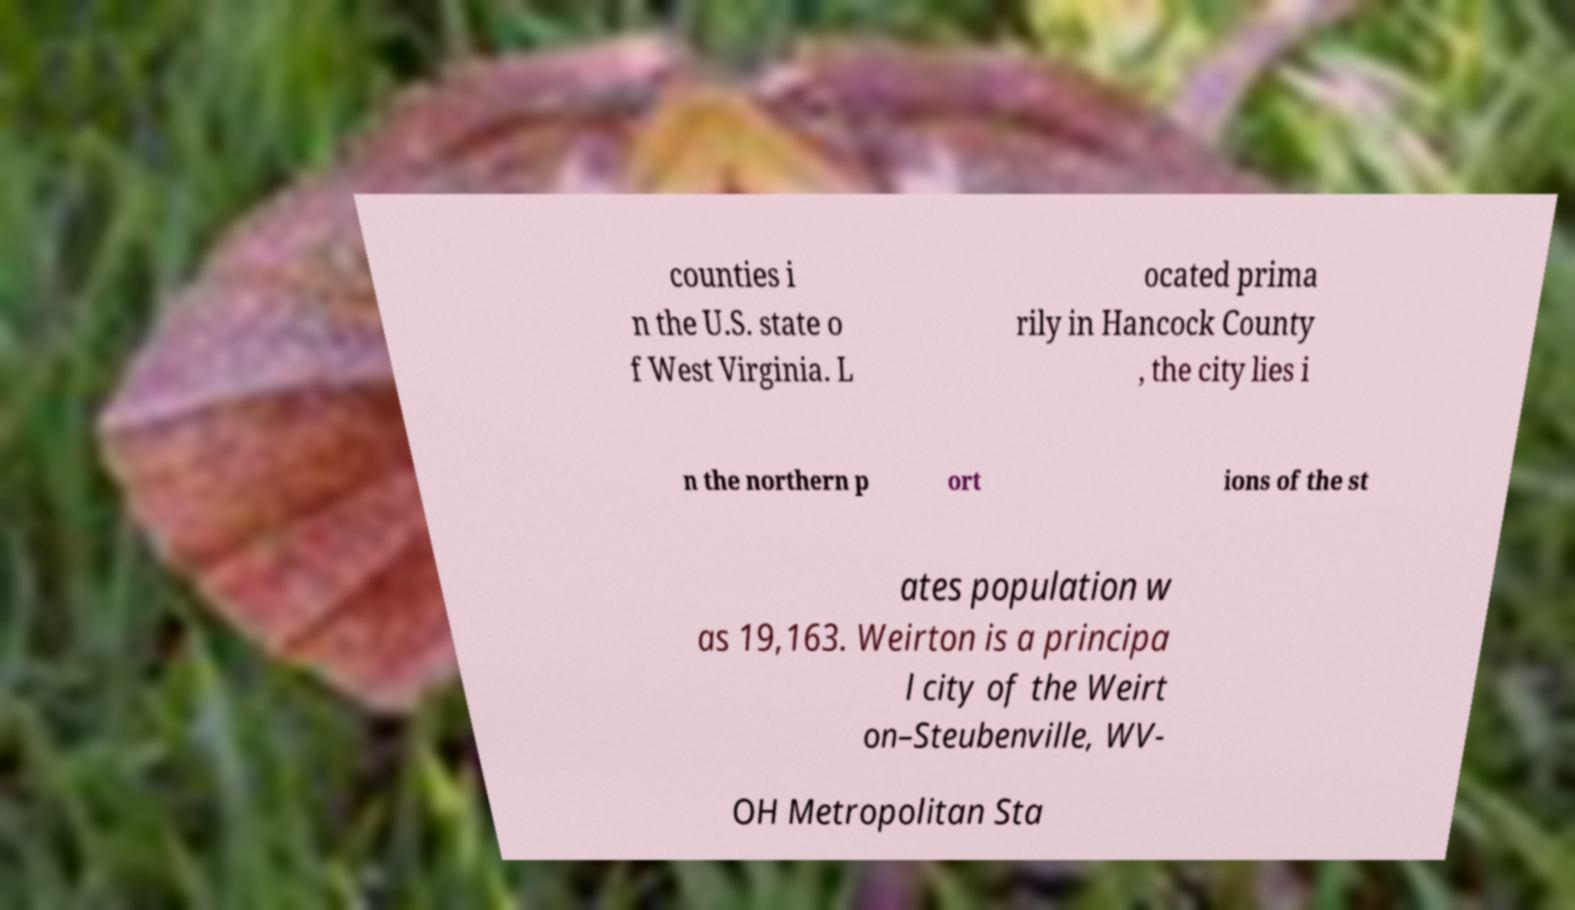Could you assist in decoding the text presented in this image and type it out clearly? counties i n the U.S. state o f West Virginia. L ocated prima rily in Hancock County , the city lies i n the northern p ort ions of the st ates population w as 19,163. Weirton is a principa l city of the Weirt on–Steubenville, WV- OH Metropolitan Sta 